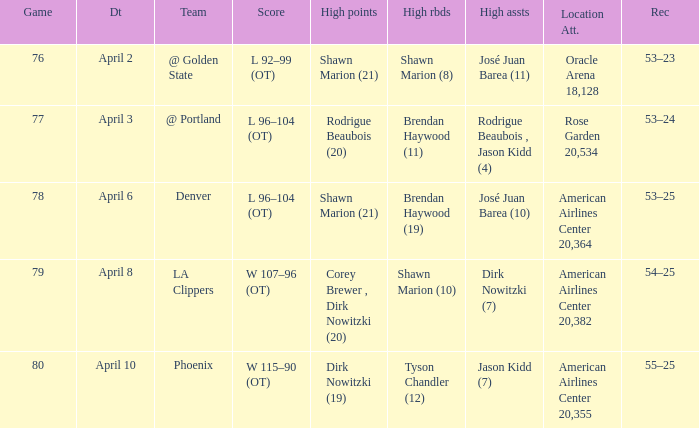What is the game number played on April 3? 77.0. 